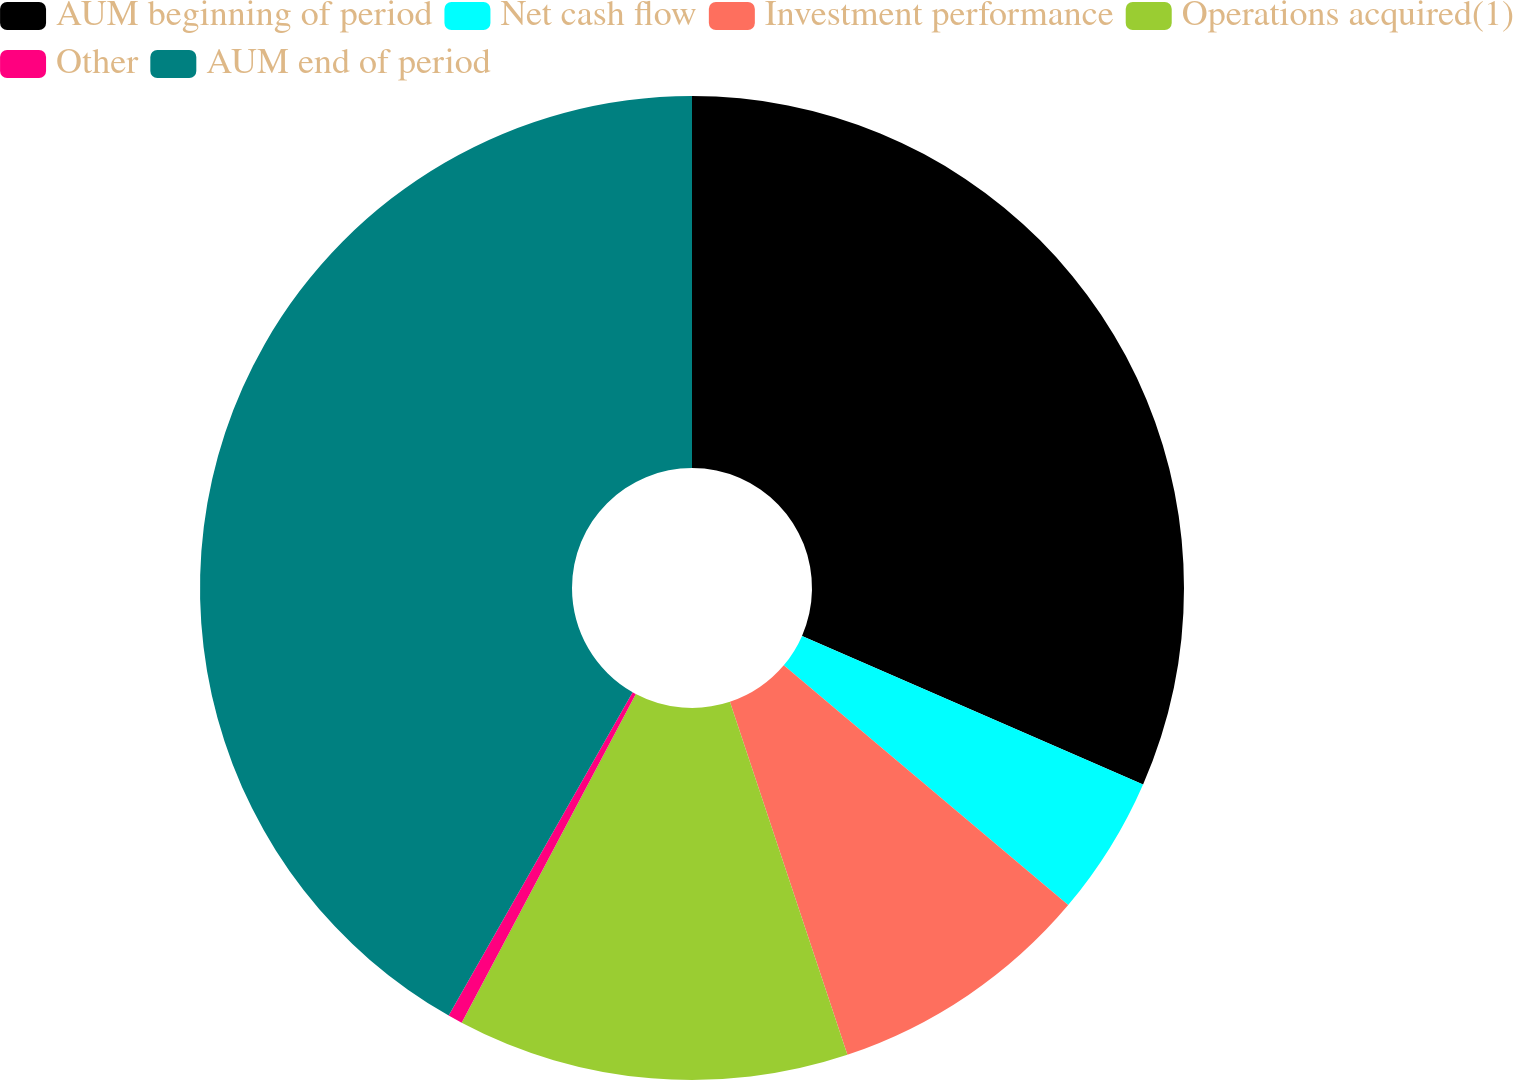Convert chart to OTSL. <chart><loc_0><loc_0><loc_500><loc_500><pie_chart><fcel>AUM beginning of period<fcel>Net cash flow<fcel>Investment performance<fcel>Operations acquired(1)<fcel>Other<fcel>AUM end of period<nl><fcel>31.54%<fcel>4.61%<fcel>8.74%<fcel>12.87%<fcel>0.48%<fcel>41.77%<nl></chart> 